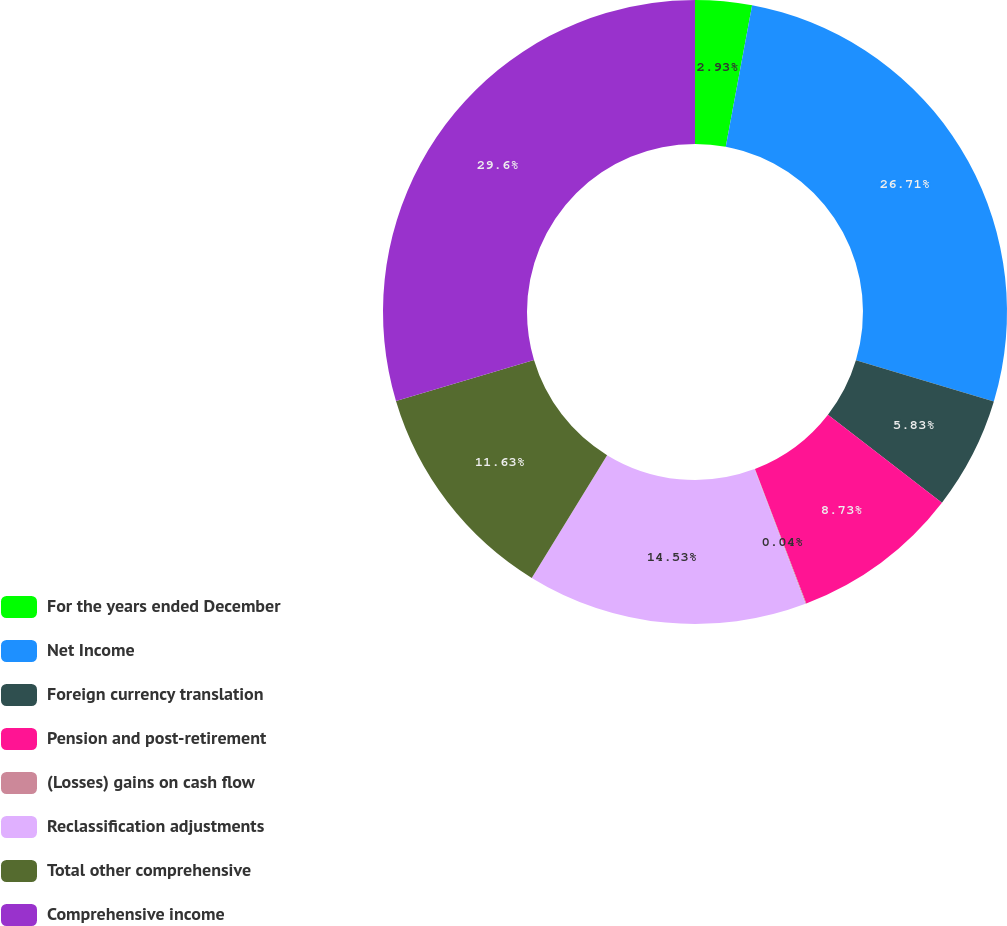Convert chart. <chart><loc_0><loc_0><loc_500><loc_500><pie_chart><fcel>For the years ended December<fcel>Net Income<fcel>Foreign currency translation<fcel>Pension and post-retirement<fcel>(Losses) gains on cash flow<fcel>Reclassification adjustments<fcel>Total other comprehensive<fcel>Comprehensive income<nl><fcel>2.93%<fcel>26.71%<fcel>5.83%<fcel>8.73%<fcel>0.04%<fcel>14.53%<fcel>11.63%<fcel>29.61%<nl></chart> 